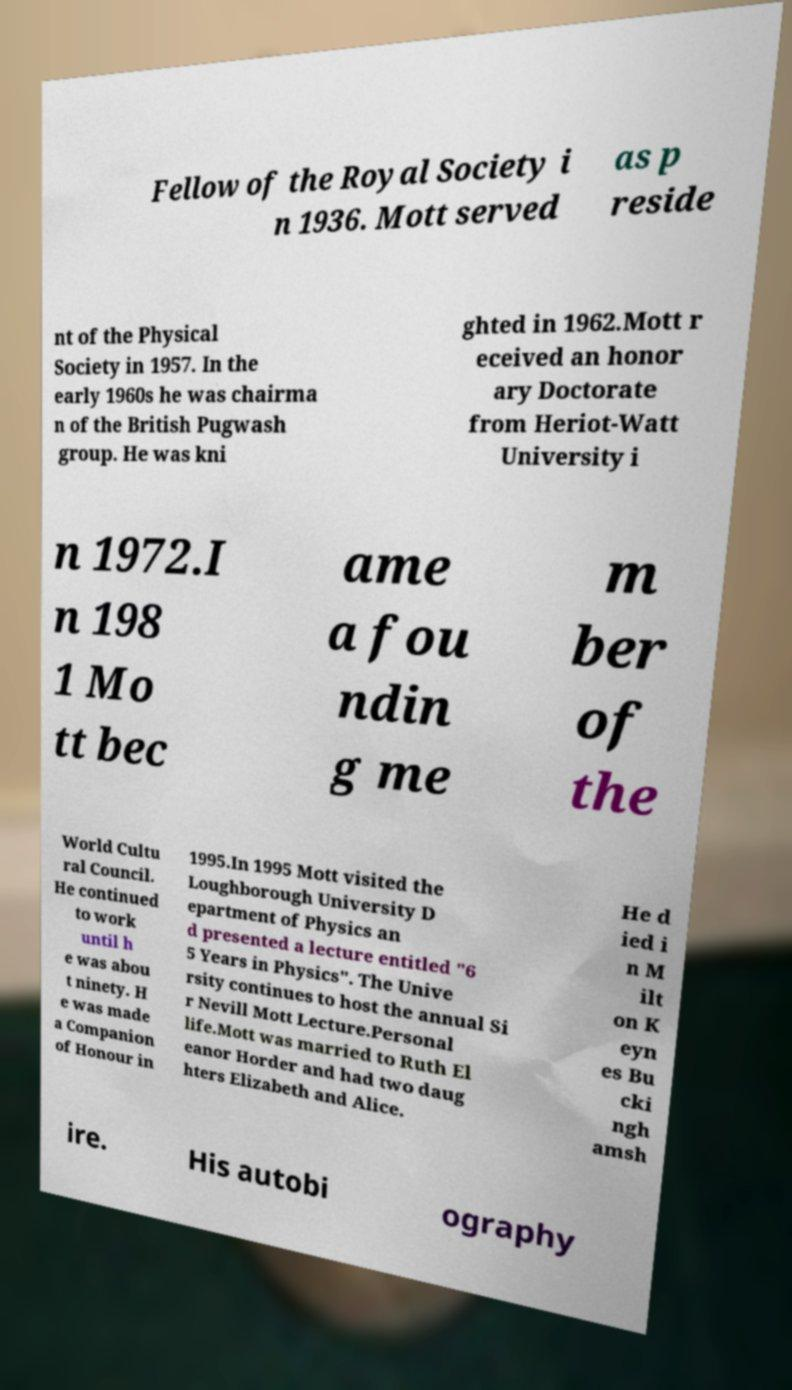I need the written content from this picture converted into text. Can you do that? Fellow of the Royal Society i n 1936. Mott served as p reside nt of the Physical Society in 1957. In the early 1960s he was chairma n of the British Pugwash group. He was kni ghted in 1962.Mott r eceived an honor ary Doctorate from Heriot-Watt University i n 1972.I n 198 1 Mo tt bec ame a fou ndin g me m ber of the World Cultu ral Council. He continued to work until h e was abou t ninety. H e was made a Companion of Honour in 1995.In 1995 Mott visited the Loughborough University D epartment of Physics an d presented a lecture entitled "6 5 Years in Physics". The Unive rsity continues to host the annual Si r Nevill Mott Lecture.Personal life.Mott was married to Ruth El eanor Horder and had two daug hters Elizabeth and Alice. He d ied i n M ilt on K eyn es Bu cki ngh amsh ire. His autobi ography 